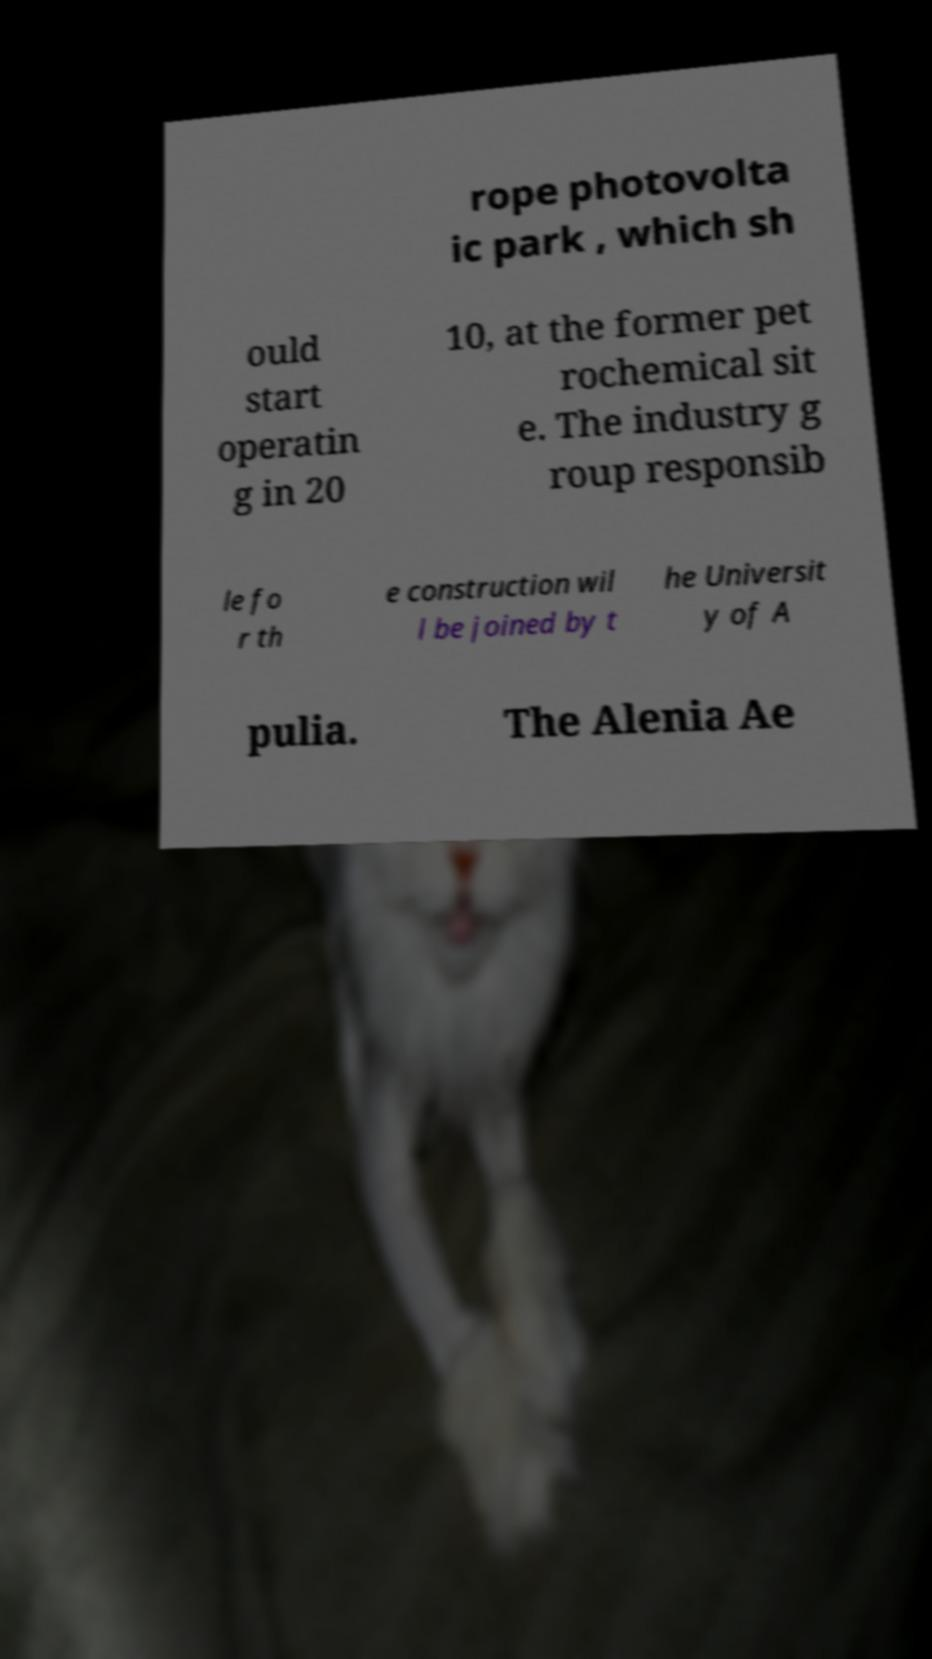Can you accurately transcribe the text from the provided image for me? rope photovolta ic park , which sh ould start operatin g in 20 10, at the former pet rochemical sit e. The industry g roup responsib le fo r th e construction wil l be joined by t he Universit y of A pulia. The Alenia Ae 